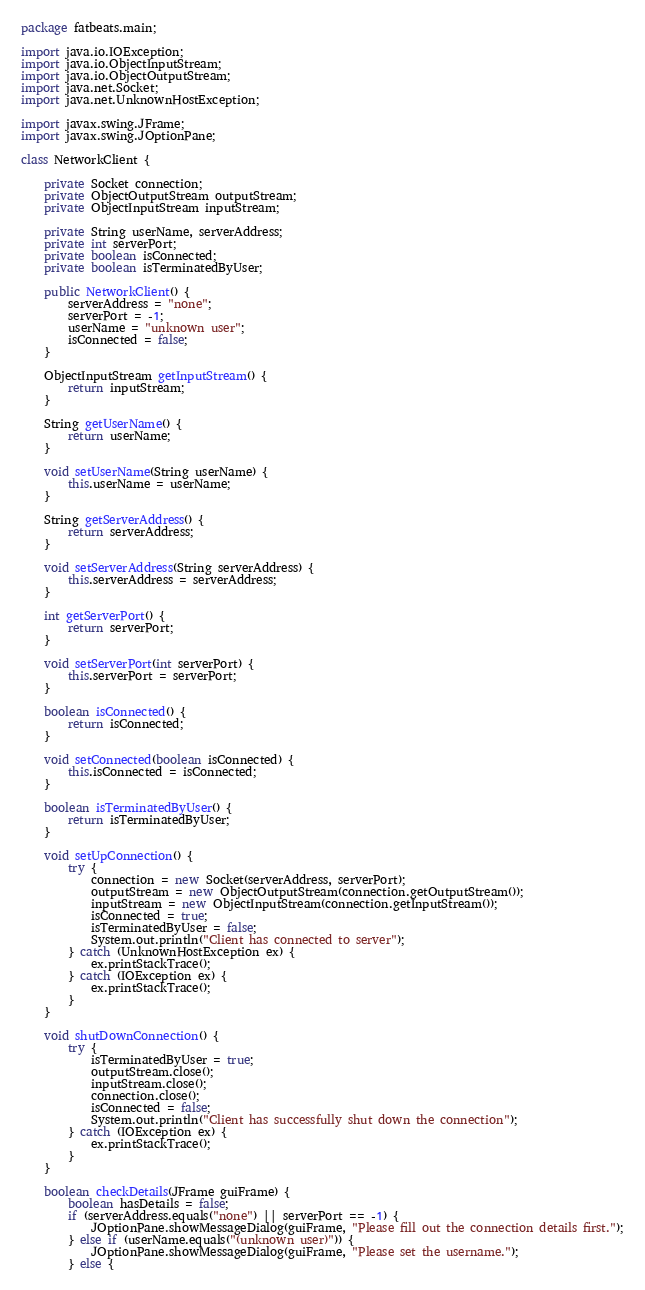Convert code to text. <code><loc_0><loc_0><loc_500><loc_500><_Java_>package fatbeats.main;

import java.io.IOException;
import java.io.ObjectInputStream;
import java.io.ObjectOutputStream;
import java.net.Socket;
import java.net.UnknownHostException;

import javax.swing.JFrame;
import javax.swing.JOptionPane;

class NetworkClient {

	private Socket connection;
	private ObjectOutputStream outputStream;
	private ObjectInputStream inputStream;

	private String userName, serverAddress;
	private int serverPort;
	private boolean isConnected;
	private boolean isTerminatedByUser;

	public NetworkClient() {
		serverAddress = "none";
		serverPort = -1;
		userName = "unknown user";
		isConnected = false;
	}

	ObjectInputStream getInputStream() {
		return inputStream;
	}

	String getUserName() {
		return userName;
	}

	void setUserName(String userName) {
		this.userName = userName;
	}

	String getServerAddress() {
		return serverAddress;
	}

	void setServerAddress(String serverAddress) {
		this.serverAddress = serverAddress;
	}

	int getServerPort() {
		return serverPort;
	}

	void setServerPort(int serverPort) {
		this.serverPort = serverPort;
	}

	boolean isConnected() {
		return isConnected;
	}

	void setConnected(boolean isConnected) {
		this.isConnected = isConnected;
	}

	boolean isTerminatedByUser() {
		return isTerminatedByUser;
	}

	void setUpConnection() {
		try {
			connection = new Socket(serverAddress, serverPort);
			outputStream = new ObjectOutputStream(connection.getOutputStream());
			inputStream = new ObjectInputStream(connection.getInputStream());
			isConnected = true;
			isTerminatedByUser = false;
			System.out.println("Client has connected to server");
		} catch (UnknownHostException ex) {
			ex.printStackTrace();
		} catch (IOException ex) {
			ex.printStackTrace();
		}
	}

	void shutDownConnection() {
		try {
			isTerminatedByUser = true;
			outputStream.close();
			inputStream.close();
			connection.close();
			isConnected = false;
			System.out.println("Client has successfully shut down the connection");
		} catch (IOException ex) {
			ex.printStackTrace();
		}
	}

	boolean checkDetails(JFrame guiFrame) {
		boolean hasDetails = false;
		if (serverAddress.equals("none") || serverPort == -1) {
			JOptionPane.showMessageDialog(guiFrame, "Please fill out the connection details first.");
		} else if (userName.equals("(unknown user)")) {
			JOptionPane.showMessageDialog(guiFrame, "Please set the username.");
		} else {</code> 